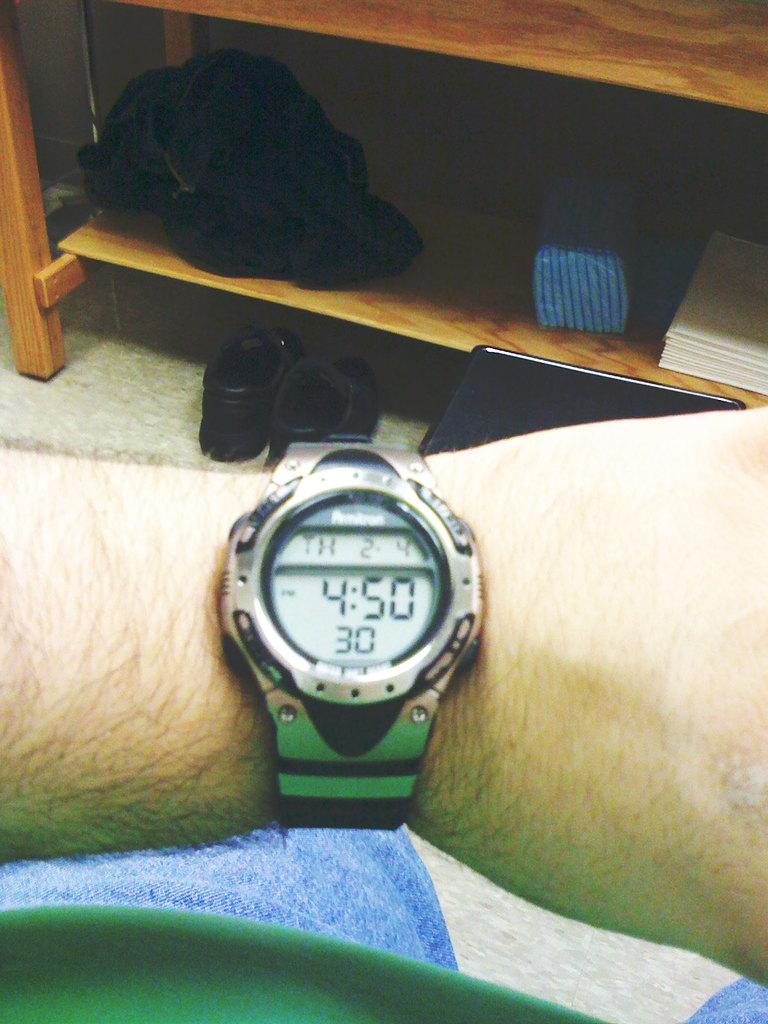<image>
Write a terse but informative summary of the picture. Wrist Watch that says 4:50 with 30 on the bottom and TH 2-4 on top. 